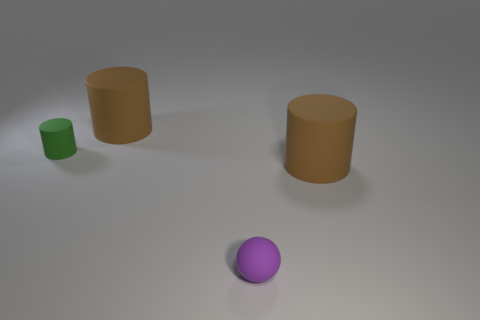Add 2 large cylinders. How many objects exist? 6 Subtract all spheres. How many objects are left? 3 Add 2 tiny purple balls. How many tiny purple balls are left? 3 Add 2 large gray metal blocks. How many large gray metal blocks exist? 2 Subtract 0 red cylinders. How many objects are left? 4 Subtract all yellow rubber objects. Subtract all large brown cylinders. How many objects are left? 2 